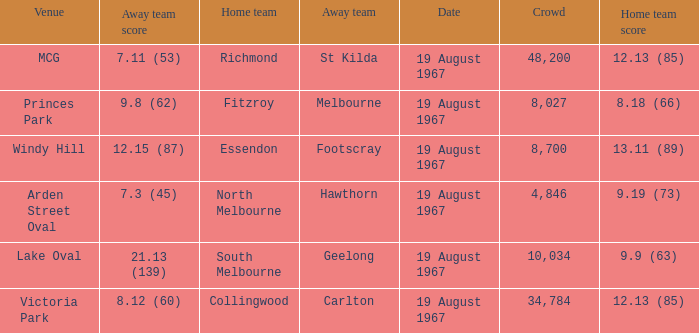When the away team scored 7.11 (53) what venue did they play at? MCG. 